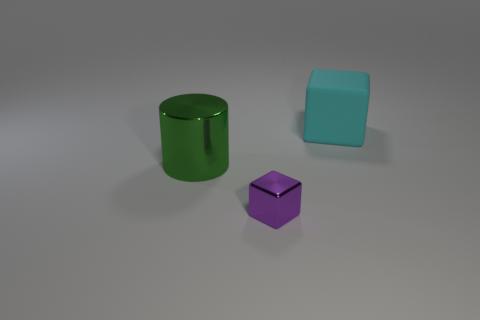Is there any other thing that is the same size as the shiny block?
Offer a terse response. No. What is the material of the thing behind the metal object that is behind the shiny thing that is right of the large green shiny cylinder?
Offer a very short reply. Rubber. What color is the metallic thing behind the object that is in front of the big metal cylinder?
Your response must be concise. Green. What number of big objects are green cylinders or blocks?
Offer a terse response. 2. What number of tiny purple objects have the same material as the small block?
Your response must be concise. 0. There is a shiny object that is left of the tiny object; what is its size?
Keep it short and to the point. Large. What is the shape of the large thing behind the large thing that is in front of the cyan block?
Keep it short and to the point. Cube. What number of shiny cubes are right of the big object right of the metal object right of the green thing?
Provide a succinct answer. 0. Are there fewer cyan matte things that are in front of the green thing than big brown shiny objects?
Offer a very short reply. No. Is there anything else that has the same shape as the big green object?
Your answer should be very brief. No. 